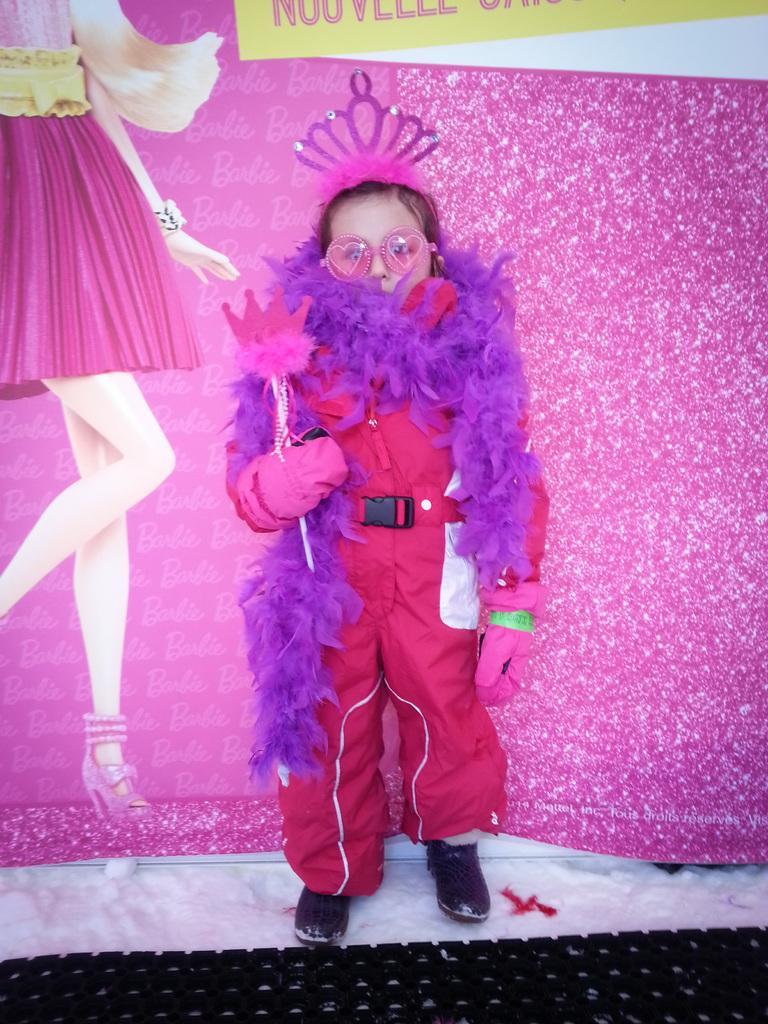Describe this image in one or two sentences. In this picture I can see child in front, who is standing and I see that this child is holding a thing and I see a crown on the head and I see the pink color background and I see depiction of a woman on the left side of this image and on the top of this image I see something is written. 